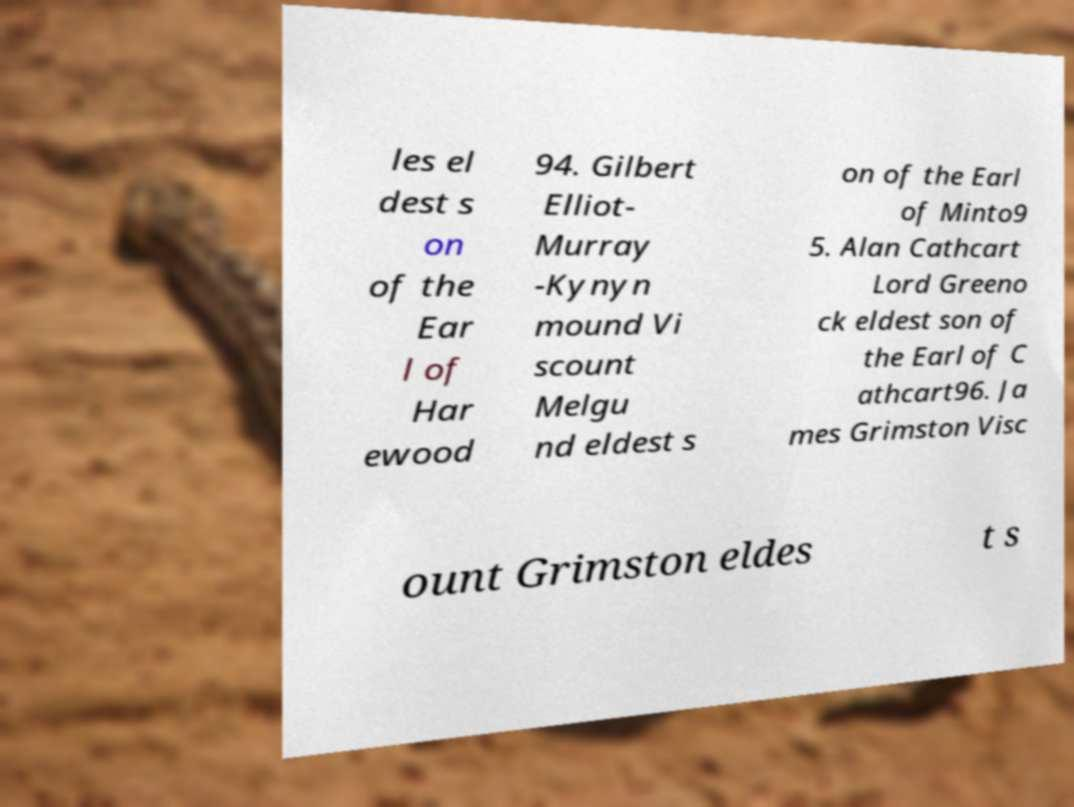Could you extract and type out the text from this image? les el dest s on of the Ear l of Har ewood 94. Gilbert Elliot- Murray -Kynyn mound Vi scount Melgu nd eldest s on of the Earl of Minto9 5. Alan Cathcart Lord Greeno ck eldest son of the Earl of C athcart96. Ja mes Grimston Visc ount Grimston eldes t s 